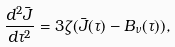Convert formula to latex. <formula><loc_0><loc_0><loc_500><loc_500>\frac { d ^ { 2 } \bar { J } } { d \tau ^ { 2 } } = 3 \zeta ( \bar { J } ( \tau ) - B _ { \nu } ( \tau ) ) ,</formula> 